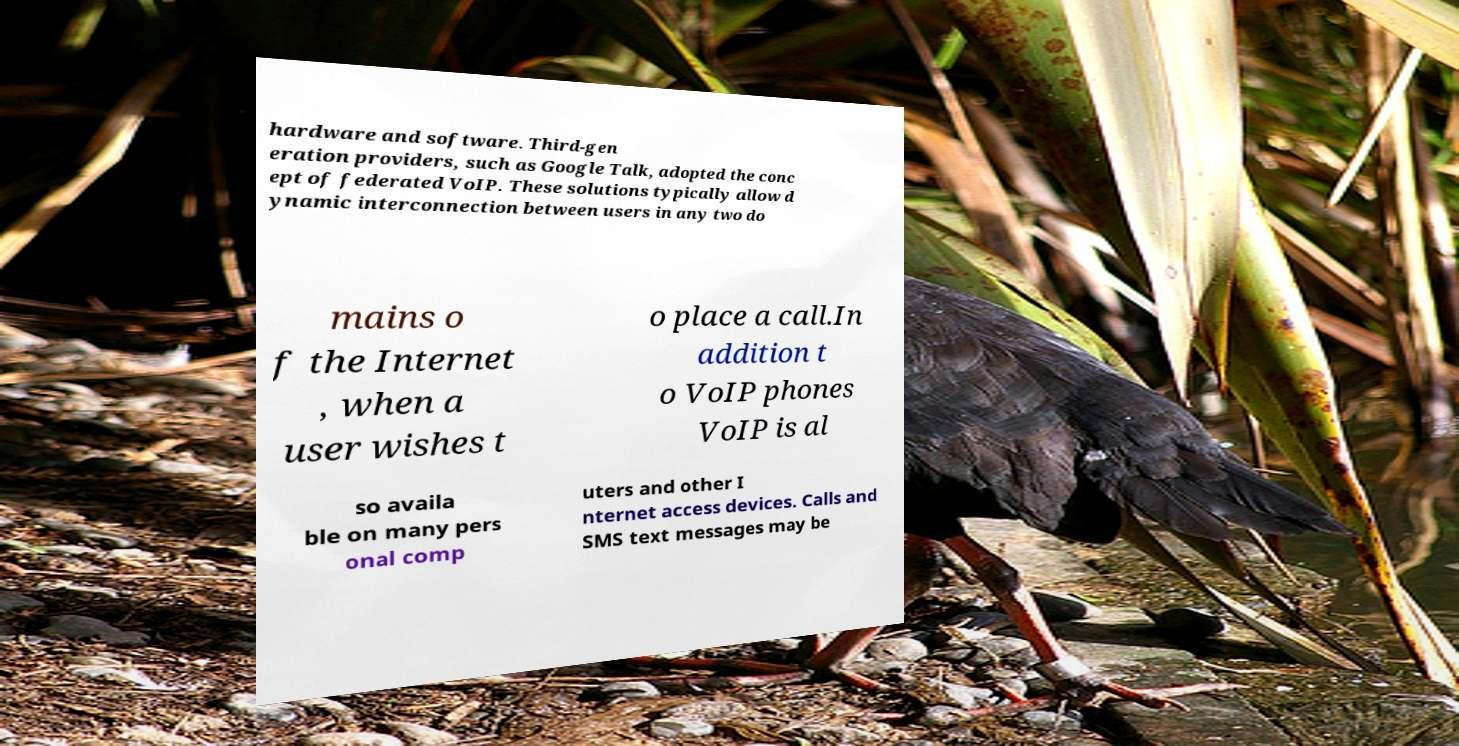There's text embedded in this image that I need extracted. Can you transcribe it verbatim? hardware and software. Third-gen eration providers, such as Google Talk, adopted the conc ept of federated VoIP. These solutions typically allow d ynamic interconnection between users in any two do mains o f the Internet , when a user wishes t o place a call.In addition t o VoIP phones VoIP is al so availa ble on many pers onal comp uters and other I nternet access devices. Calls and SMS text messages may be 